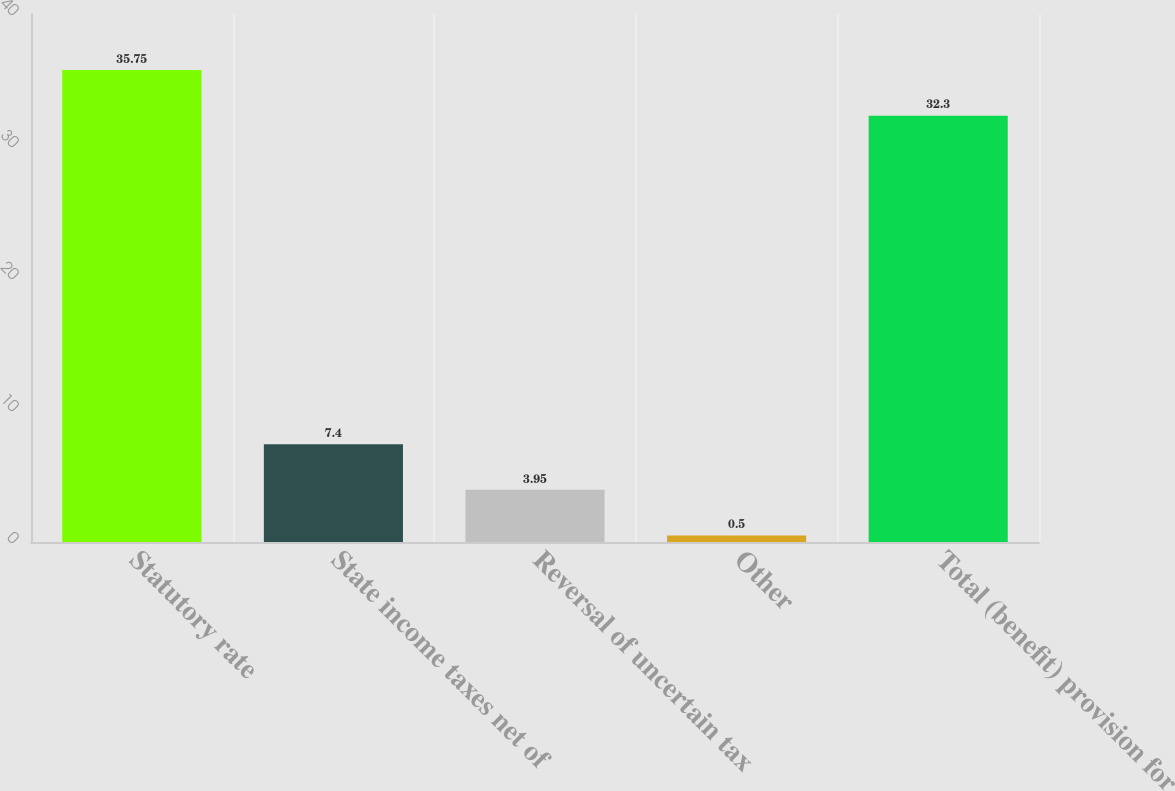Convert chart. <chart><loc_0><loc_0><loc_500><loc_500><bar_chart><fcel>Statutory rate<fcel>State income taxes net of<fcel>Reversal of uncertain tax<fcel>Other<fcel>Total (benefit) provision for<nl><fcel>35.75<fcel>7.4<fcel>3.95<fcel>0.5<fcel>32.3<nl></chart> 